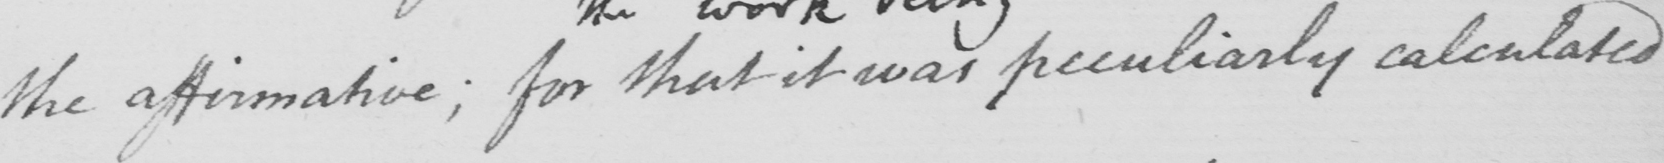Please transcribe the handwritten text in this image. the affirmative ; for that it was peculiarly calculated 